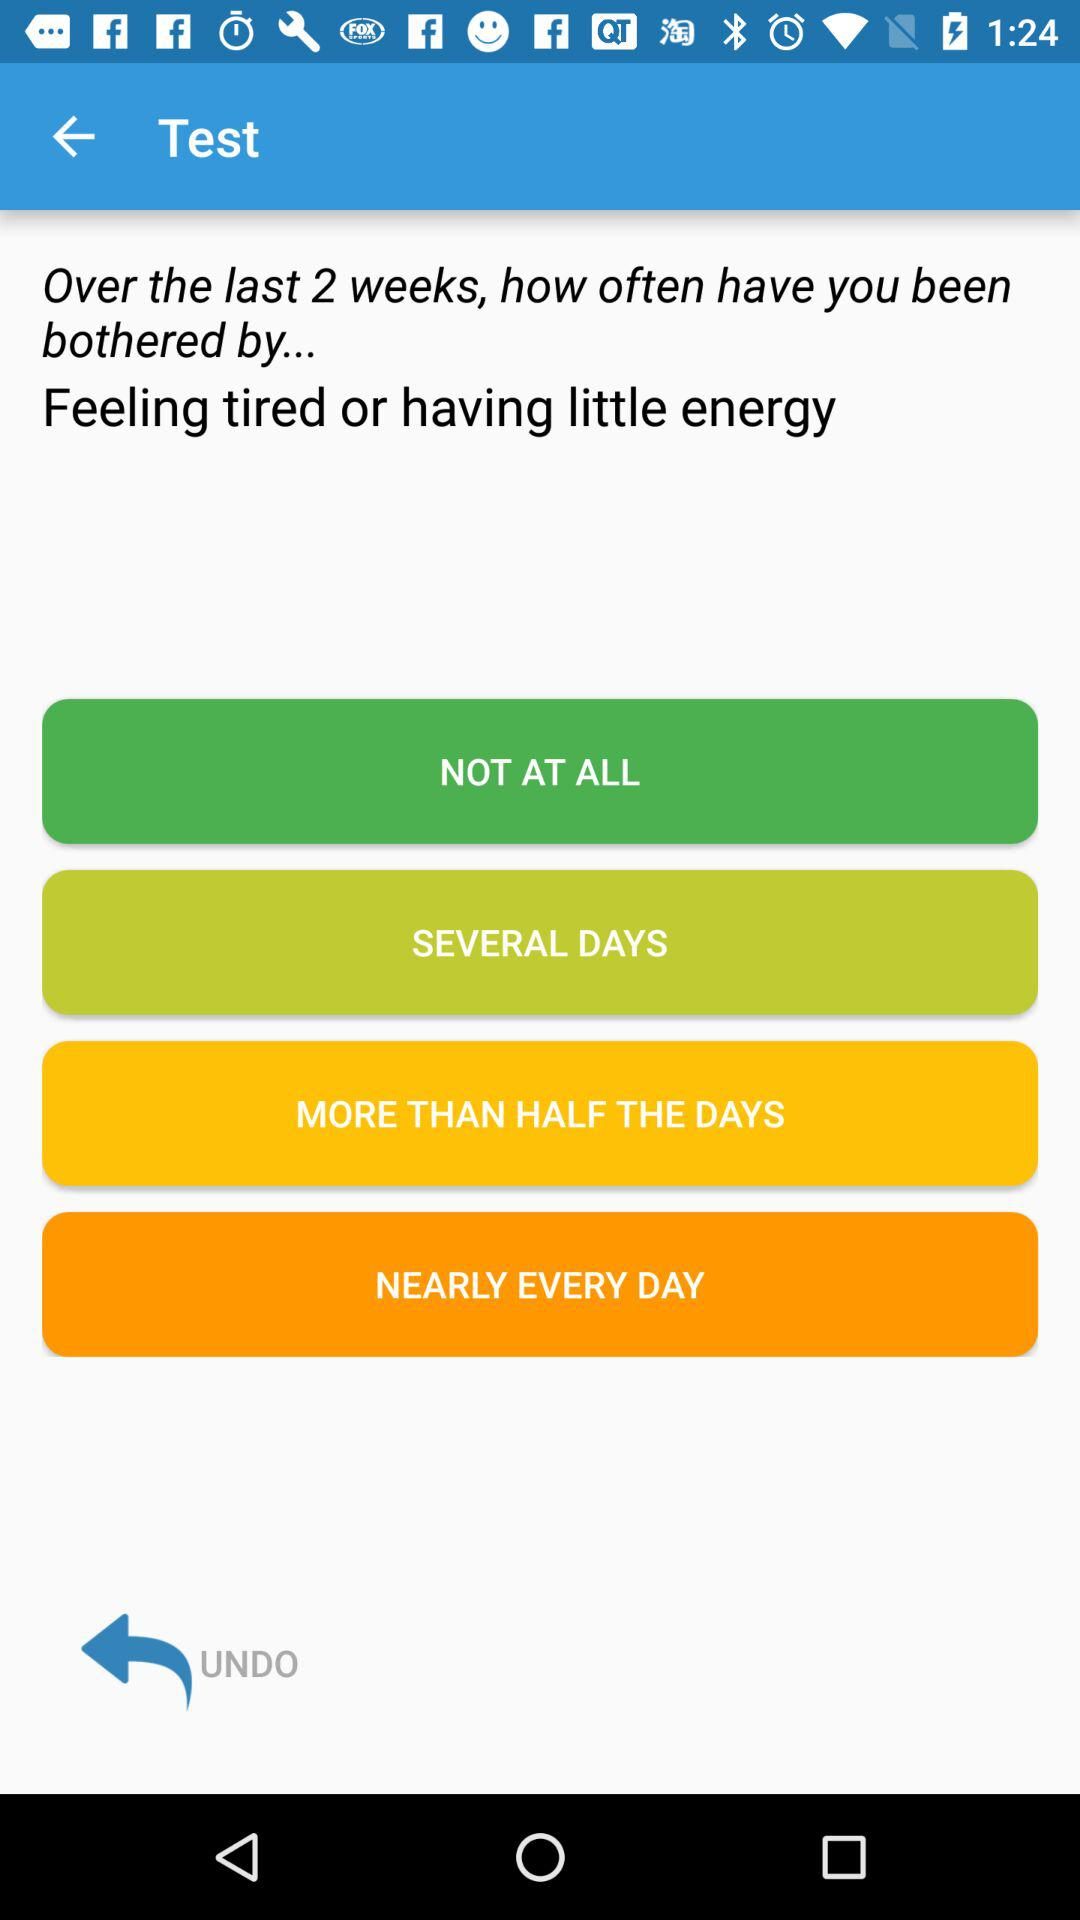Which option is selected?
When the provided information is insufficient, respond with <no answer>. <no answer> 